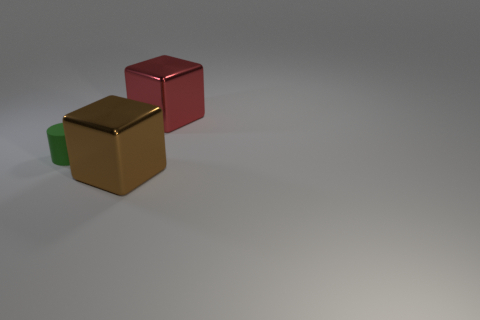Is there anything else that is made of the same material as the red thing?
Keep it short and to the point. Yes. What number of small things are either brown metallic blocks or blue shiny cubes?
Offer a terse response. 0. Is the material of the big block in front of the green thing the same as the red block?
Your response must be concise. Yes. There is a big cube that is in front of the thing that is on the left side of the brown shiny object; what is its material?
Keep it short and to the point. Metal. What number of big brown metal objects are the same shape as the red metallic thing?
Offer a terse response. 1. How big is the block that is to the left of the big block to the right of the large shiny block that is in front of the red block?
Your answer should be very brief. Large. What number of blue objects are objects or metallic things?
Make the answer very short. 0. There is a object right of the brown metallic object; does it have the same shape as the matte object?
Provide a succinct answer. No. Is the number of large brown metal cubes that are left of the big brown metal object greater than the number of small things?
Your answer should be very brief. No. How many green metallic things are the same size as the brown shiny object?
Provide a short and direct response. 0. 